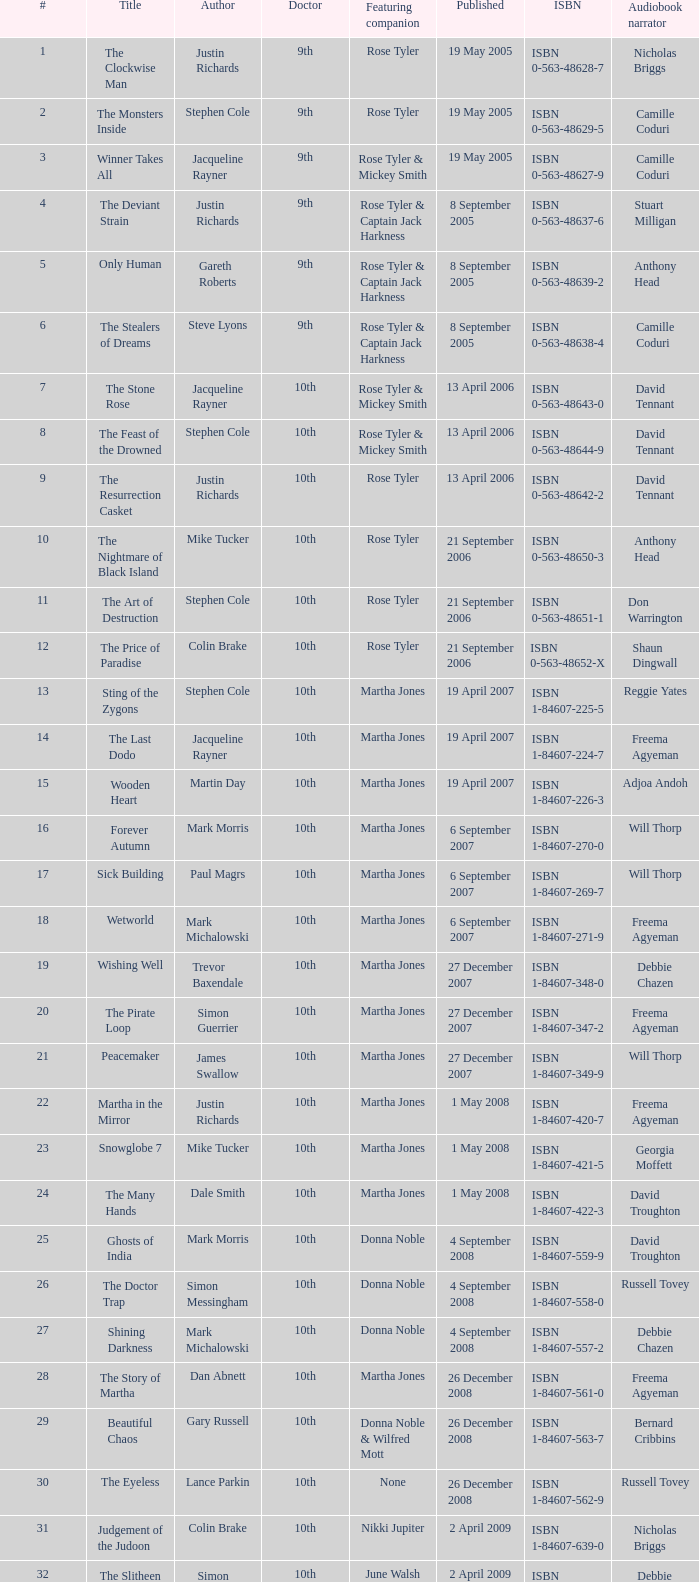What is the designation of book 8? The Feast of the Drowned. 